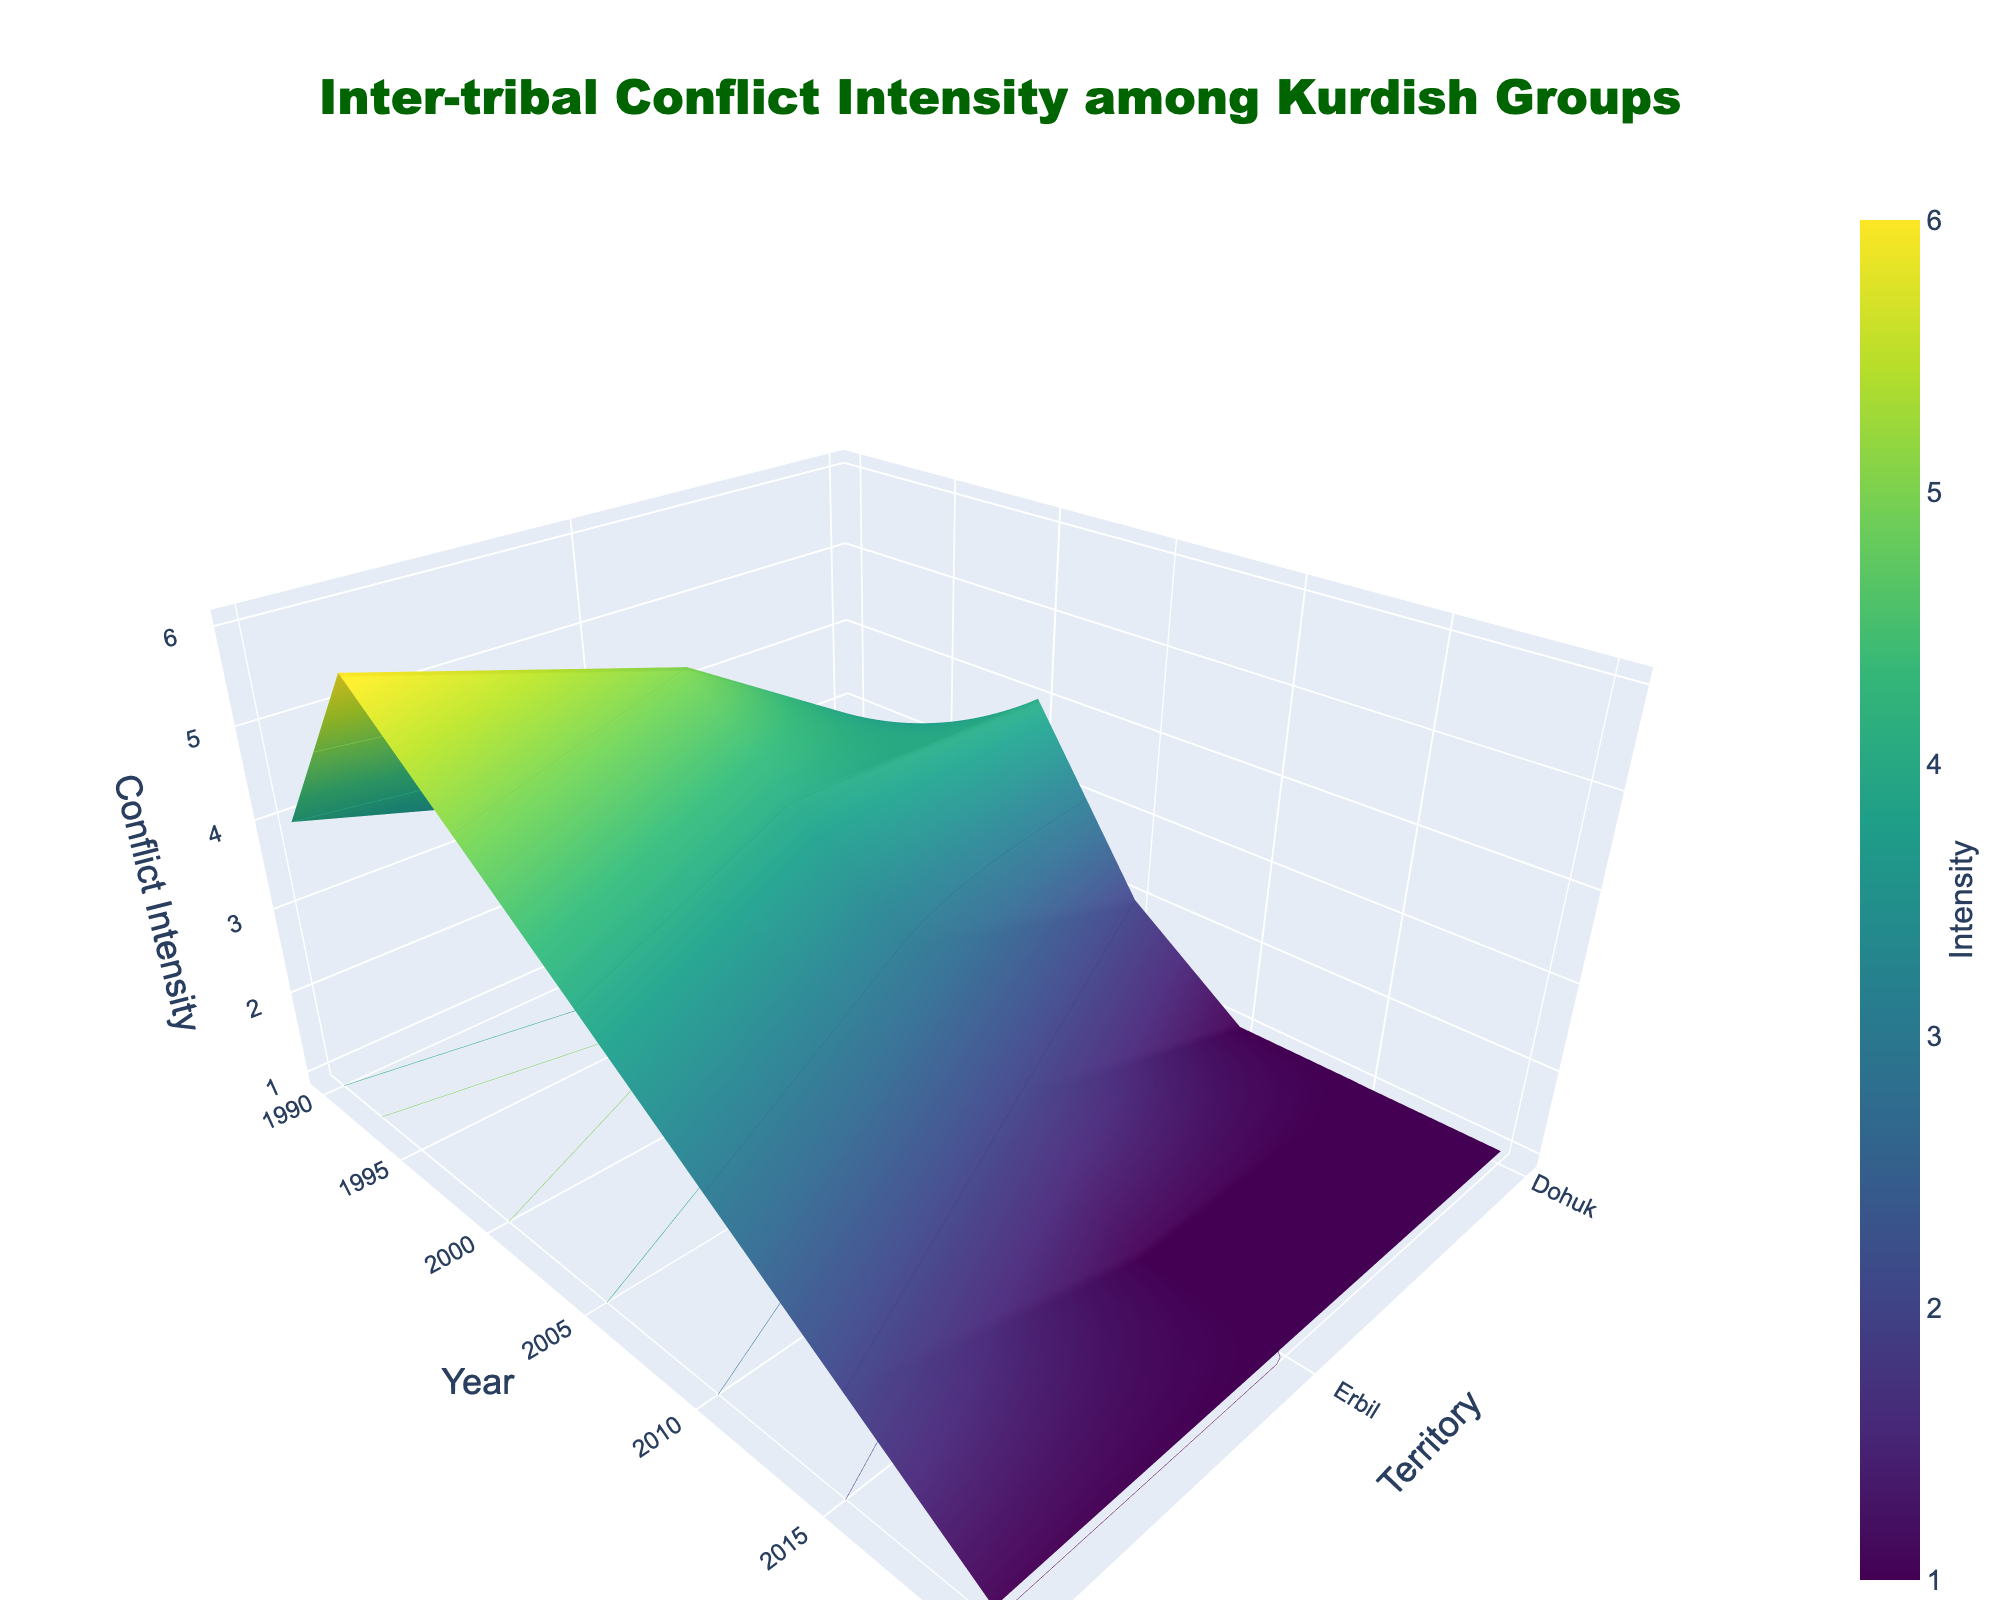How does the conflict intensity in Dohuk change over the years? The figure shows the vertical axis representing conflict intensity for Dohuk at different years. By inspecting the intensity values, we observe the change from 2 in 1990, 3 in 1995, 4 in 2000, 2 in 2005, 1 in 2010, and remaining 1 in 2015 and 2020.
Answer: It decreases Which territory had the highest conflict intensity in 1995, and what was the value? By looking at the intensity values for 1995, Erbil shows the highest intensity with a value of 5 compared to Dohuk (3) and Sulaymaniyah (6).
Answer: Sulaymaniyah, 6 Did the conflict intensity in Sulaymaniyah ever decrease during the years shown? Examining the vertical variations in Sulaymaniyah's intensity values, we can see that it decreased from 6 in 1995 to 5 in 2000 and continued to decrease steadily to 4 in 2005, 3 in 2010, 2 in 2015, and finally 1 in 2020.
Answer: Yes Between which years did Erbil see the most significant decrease in conflict intensity? The conflict intensities for Erbil across years are 3 (1990), 5 (1995), 4 (2000), 3 (2005), 2 (2010), 1 (2015), and 1 (2020). The most significant drop is between 2010 to 2015, where it dropped from 2 to 1.
Answer: 2010 to 2015 What is the overall trend of conflict intensity in Dohuk from 1990 to 2020? By observing the intensity values for Dohuk from the figure, it started at 2 in 1990, increased to 3 in 1995 and 4 in 2000, then decreased to 2 in 2005 and further to 1 in 2010, maintaining at 1 till 2020. Thus, the overall trend is increasing initially and then decreasing sharply.
Answer: Decreasing Which year appears to have the overall lowest conflict intensity across all territories? By investigating each year and comparing the intensity values across territories, 2020 has the lowest with Dohuk (1), Erbil (1), and Sulaymaniyah (1).
Answer: 2020 What can you infer about the conflict intensity trends among the three territories from 2005 to 2020? From the years 2005 to 2020, the conflict intensity in Dohuk went from 2 to 1, in Erbil from 3 to 1, and in Sulaymaniyah from 4 to 1. The overall trend indicates a steady decline in conflict intensities in all three territories.
Answer: Decreasing trend Between Erbil and Sulaymaniyah, which territory shows more consistent decline in conflict intensity over the years? Observing the intensity values, Sulaymaniyah has a more consistent decline compared to Erbil. From 1995, Erbil showed 5 to 4 (2000), 3 (2005), 2 (2010), 1 (2015,2020). Sulaymaniyah was more consistent from 6 (1995), 5 (2000), 4 (2005), 3 (2010), 2 (2015), 1 (2020).
Answer: Sulaymaniyah What does the color scheme used by the 3D surface plot indicate? The colors in a Viridis color scale represent the conflict intensity values, with darker shades typically indicating higher intensities and lighter shades indicating lower intensities.
Answer: Intensity levels 